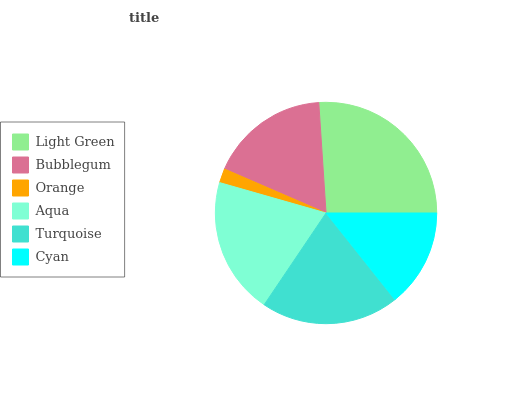Is Orange the minimum?
Answer yes or no. Yes. Is Light Green the maximum?
Answer yes or no. Yes. Is Bubblegum the minimum?
Answer yes or no. No. Is Bubblegum the maximum?
Answer yes or no. No. Is Light Green greater than Bubblegum?
Answer yes or no. Yes. Is Bubblegum less than Light Green?
Answer yes or no. Yes. Is Bubblegum greater than Light Green?
Answer yes or no. No. Is Light Green less than Bubblegum?
Answer yes or no. No. Is Aqua the high median?
Answer yes or no. Yes. Is Bubblegum the low median?
Answer yes or no. Yes. Is Turquoise the high median?
Answer yes or no. No. Is Aqua the low median?
Answer yes or no. No. 